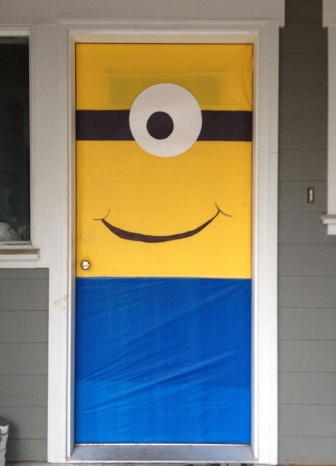This door decoration is pretty fun! What are some creative ideas for other themed door decorations? Absolutely! Here are some creative ideas for themed door decorations: 1) Superhero Door: Use colors and symbols associated with popular superheroes like Batman, Spider-Man, or Wonder Woman. 2) Seasonal Themes: Decorate with themes like a snowman in winter, a blossoming tree in spring, or a haunted house for Halloween. 3) Movie Characters: Similar to the minion, you could use characters from movies such as Harry Potter, Frozen, or Toy Story. 4) Underwater Wonderland: Create an underwater scene with fish, seaweed, and mermaids, using shades of blue and green. 5) Space Adventure: Decorate your door with spaceships, stars, and planets to give it a galactic feel. These ideas can make your door stand out and bring joy to anyone who sees it! 